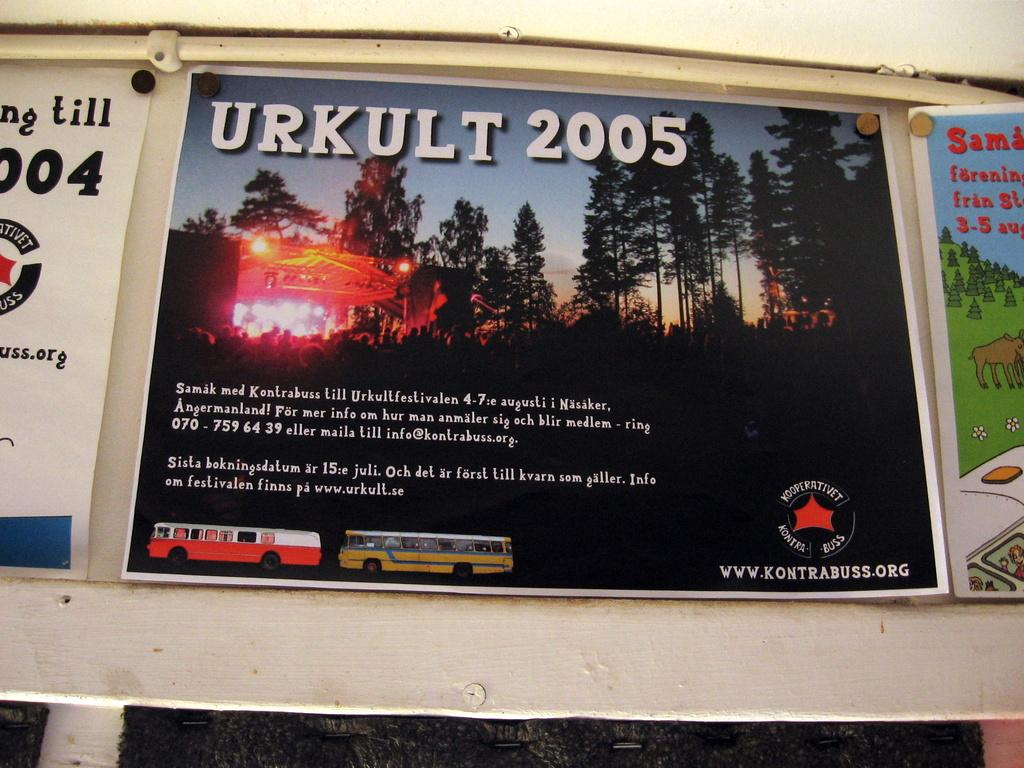Provide a one-sentence caption for the provided image. An advertisment that says Urkult 2005 across the top. 